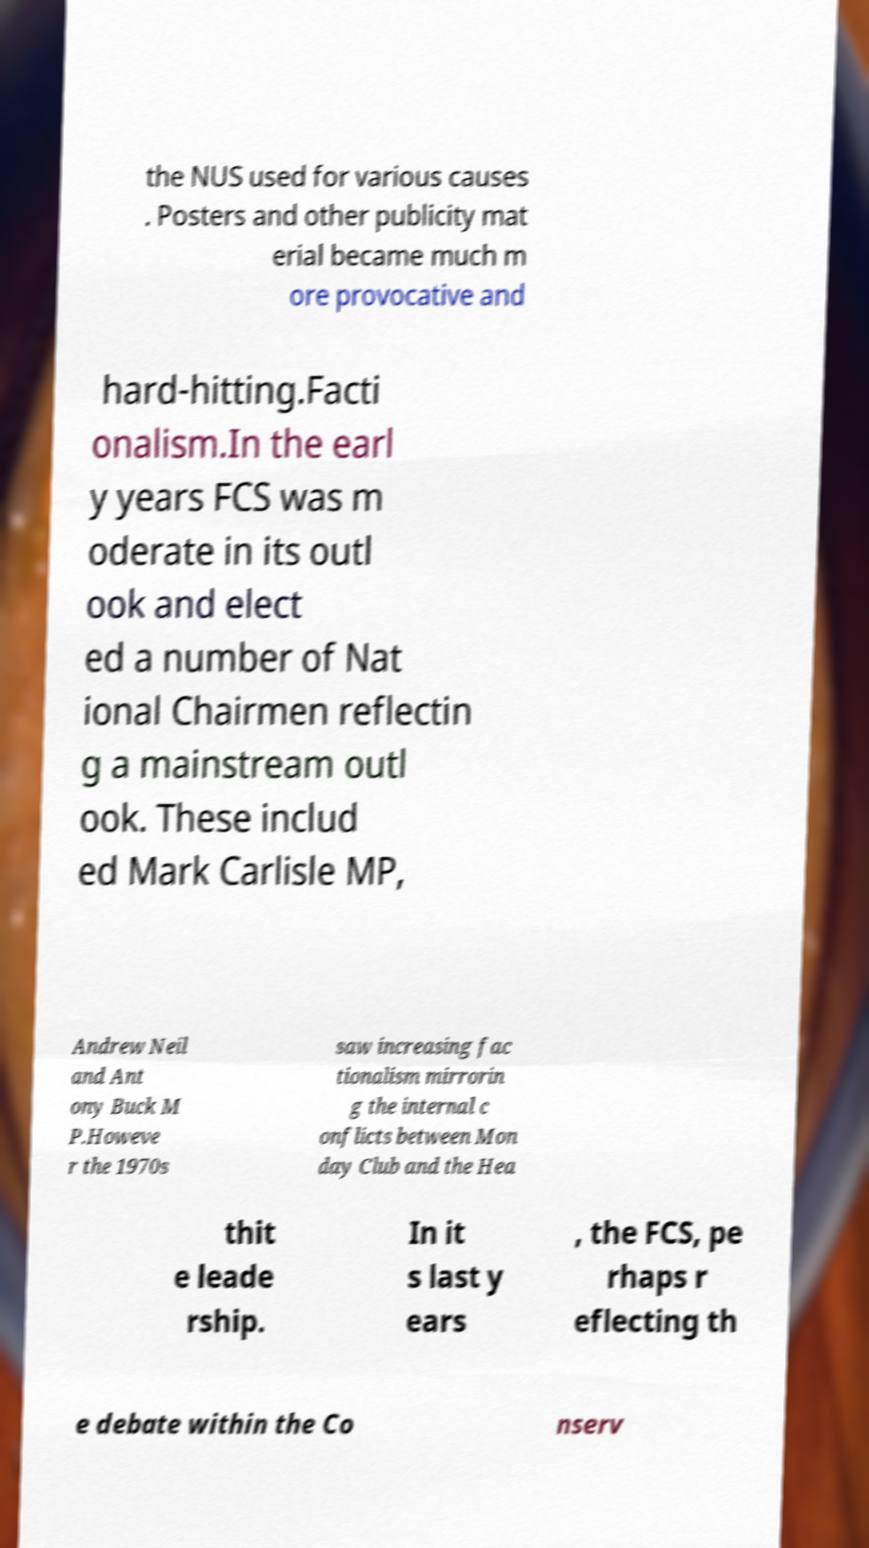What messages or text are displayed in this image? I need them in a readable, typed format. the NUS used for various causes . Posters and other publicity mat erial became much m ore provocative and hard-hitting.Facti onalism.In the earl y years FCS was m oderate in its outl ook and elect ed a number of Nat ional Chairmen reflectin g a mainstream outl ook. These includ ed Mark Carlisle MP, Andrew Neil and Ant ony Buck M P.Howeve r the 1970s saw increasing fac tionalism mirrorin g the internal c onflicts between Mon day Club and the Hea thit e leade rship. In it s last y ears , the FCS, pe rhaps r eflecting th e debate within the Co nserv 